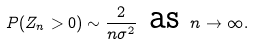Convert formula to latex. <formula><loc_0><loc_0><loc_500><loc_500>P ( Z _ { n } > 0 ) \sim \frac { 2 } { n \sigma ^ { 2 } } \text { as } n \to \infty .</formula> 